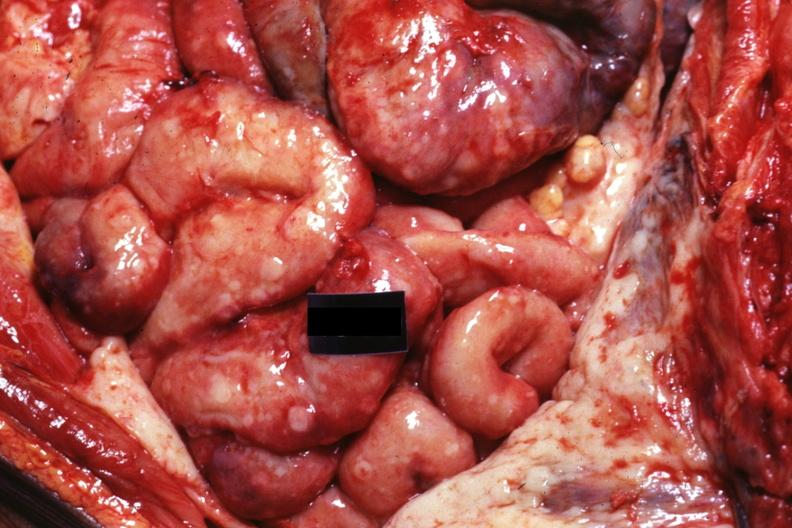does this image show in situ natural color very good?
Answer the question using a single word or phrase. Yes 